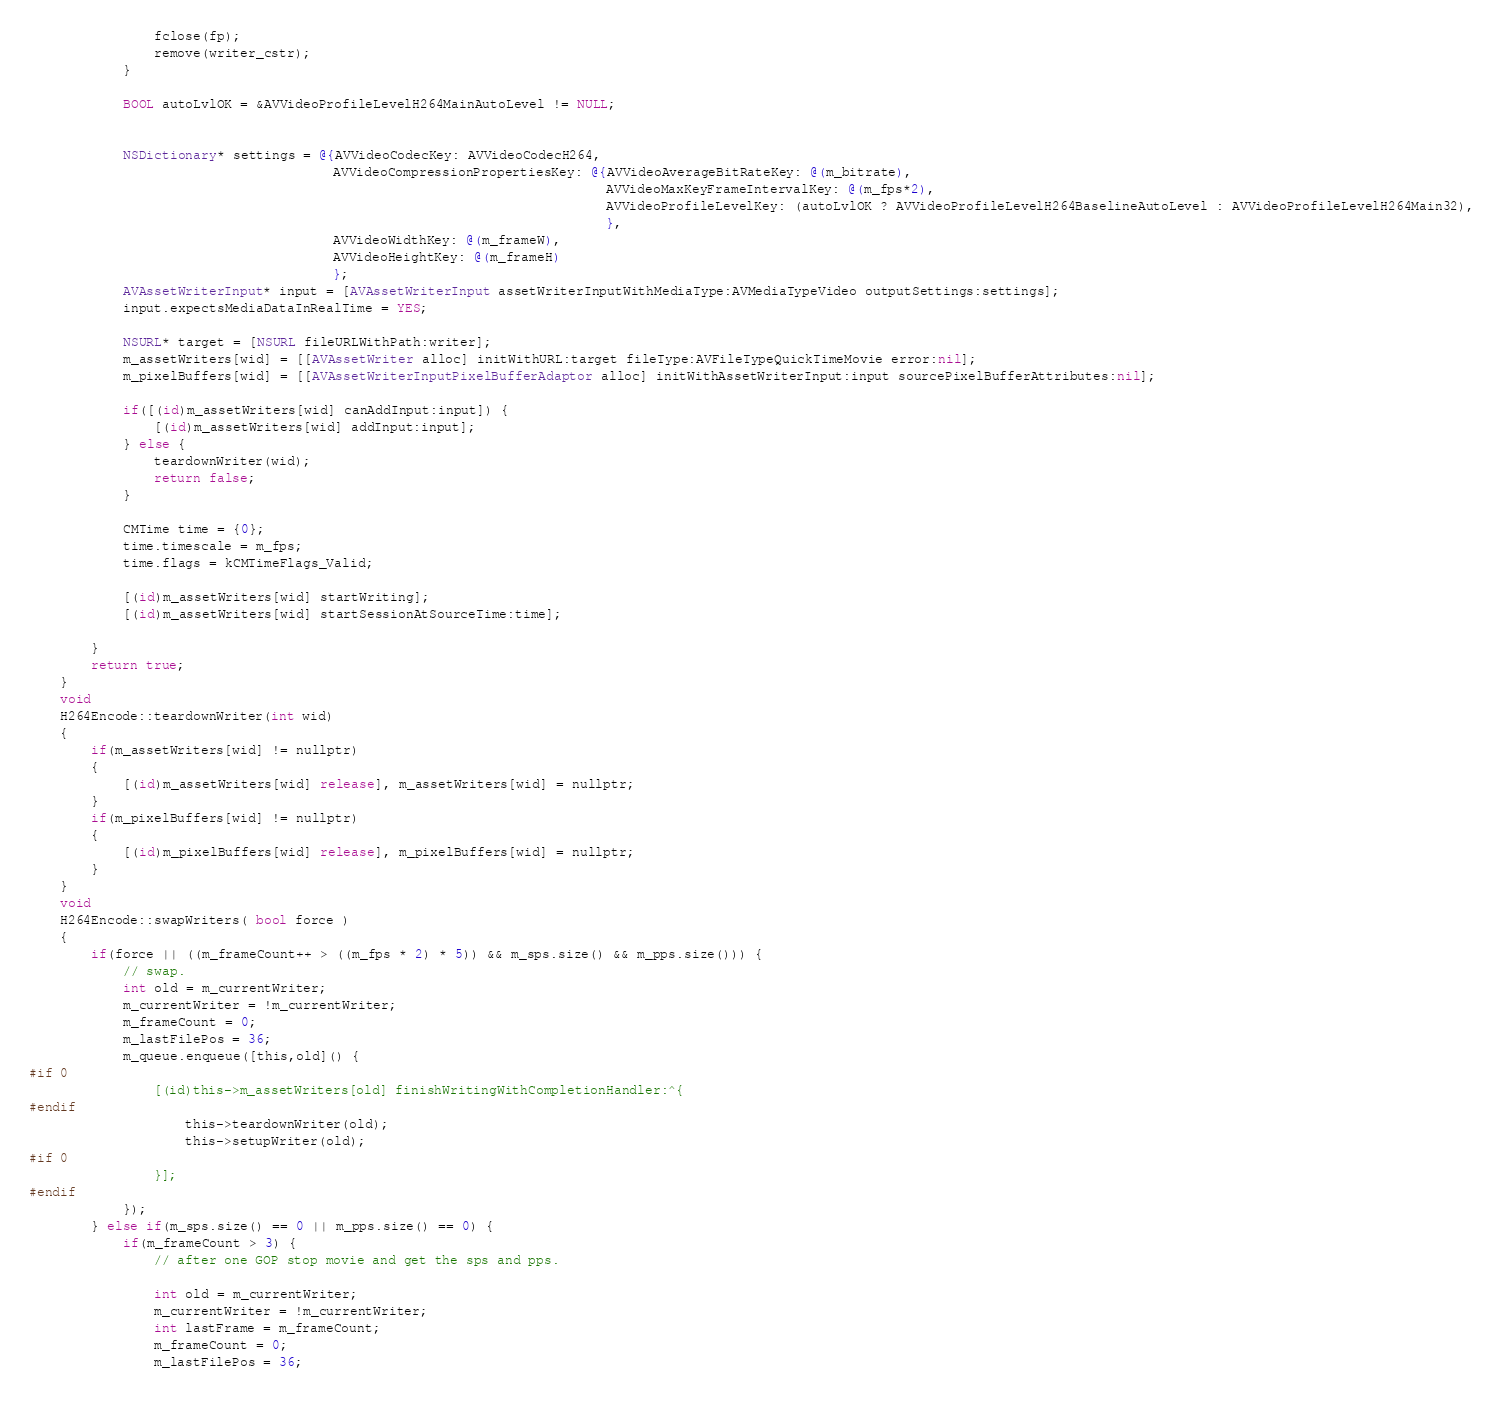<code> <loc_0><loc_0><loc_500><loc_500><_ObjectiveC_>                fclose(fp);
                remove(writer_cstr);
            }
            
            BOOL autoLvlOK = &AVVideoProfileLevelH264MainAutoLevel != NULL;
            
            
            NSDictionary* settings = @{AVVideoCodecKey: AVVideoCodecH264,
                                       AVVideoCompressionPropertiesKey: @{AVVideoAverageBitRateKey: @(m_bitrate),
                                                                          AVVideoMaxKeyFrameIntervalKey: @(m_fps*2),
                                                                          AVVideoProfileLevelKey: (autoLvlOK ? AVVideoProfileLevelH264BaselineAutoLevel : AVVideoProfileLevelH264Main32),
                                                                          },
                                       AVVideoWidthKey: @(m_frameW),
                                       AVVideoHeightKey: @(m_frameH)
                                       };
            AVAssetWriterInput* input = [AVAssetWriterInput assetWriterInputWithMediaType:AVMediaTypeVideo outputSettings:settings];
            input.expectsMediaDataInRealTime = YES;
            
            NSURL* target = [NSURL fileURLWithPath:writer];
            m_assetWriters[wid] = [[AVAssetWriter alloc] initWithURL:target fileType:AVFileTypeQuickTimeMovie error:nil];
            m_pixelBuffers[wid] = [[AVAssetWriterInputPixelBufferAdaptor alloc] initWithAssetWriterInput:input sourcePixelBufferAttributes:nil];
            
            if([(id)m_assetWriters[wid] canAddInput:input]) {
                [(id)m_assetWriters[wid] addInput:input];
            } else {
                teardownWriter(wid);
                return false;
            }
            
            CMTime time = {0};
            time.timescale = m_fps;
            time.flags = kCMTimeFlags_Valid;
            
            [(id)m_assetWriters[wid] startWriting];
            [(id)m_assetWriters[wid] startSessionAtSourceTime:time];
            
        }
        return true;
    }
    void
    H264Encode::teardownWriter(int wid)
    {
        if(m_assetWriters[wid] != nullptr)
        {
            [(id)m_assetWriters[wid] release], m_assetWriters[wid] = nullptr;
        }
        if(m_pixelBuffers[wid] != nullptr)
        {
            [(id)m_pixelBuffers[wid] release], m_pixelBuffers[wid] = nullptr;
        }
    }
    void
    H264Encode::swapWriters( bool force )
    {
        if(force || ((m_frameCount++ > ((m_fps * 2) * 5)) && m_sps.size() && m_pps.size())) {
            // swap.
            int old = m_currentWriter;
            m_currentWriter = !m_currentWriter;
            m_frameCount = 0;
            m_lastFilePos = 36;
            m_queue.enqueue([this,old]() {
#if 0
                [(id)this->m_assetWriters[old] finishWritingWithCompletionHandler:^{
#endif
                    this->teardownWriter(old);
                    this->setupWriter(old);
#if 0
                }];
#endif
            });
        } else if(m_sps.size() == 0 || m_pps.size() == 0) {
            if(m_frameCount > 3) {
                // after one GOP stop movie and get the sps and pps.
                
                int old = m_currentWriter;
                m_currentWriter = !m_currentWriter;
                int lastFrame = m_frameCount;
                m_frameCount = 0;
                m_lastFilePos = 36;
                </code> 